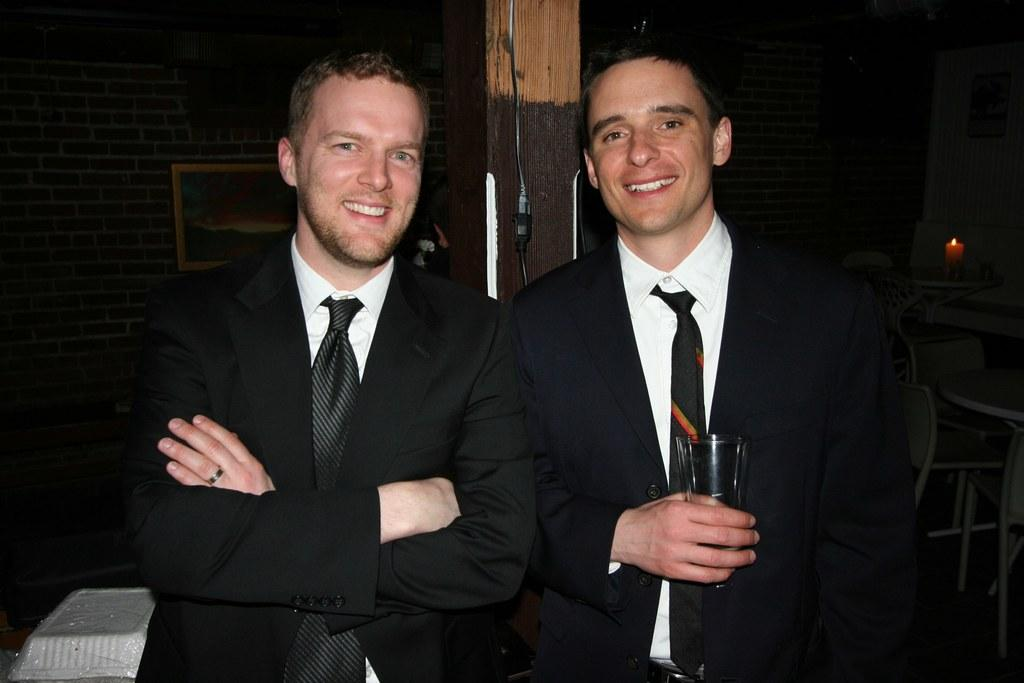How many people are in the image? There are two persons in the image. What are the persons wearing? Both persons are wearing black suits. What expression do the persons have? The persons are smiling. What is one person holding in the image? One person is holding a glass. What can be seen in the background of the image? The background of the image is dark. What type of seed can be seen growing on the person's shoulder in the image? There is no seed visible on any person's shoulder in the image. What kind of hook is attached to the person's belt in the image? There is no hook visible on any person's belt in the image. 